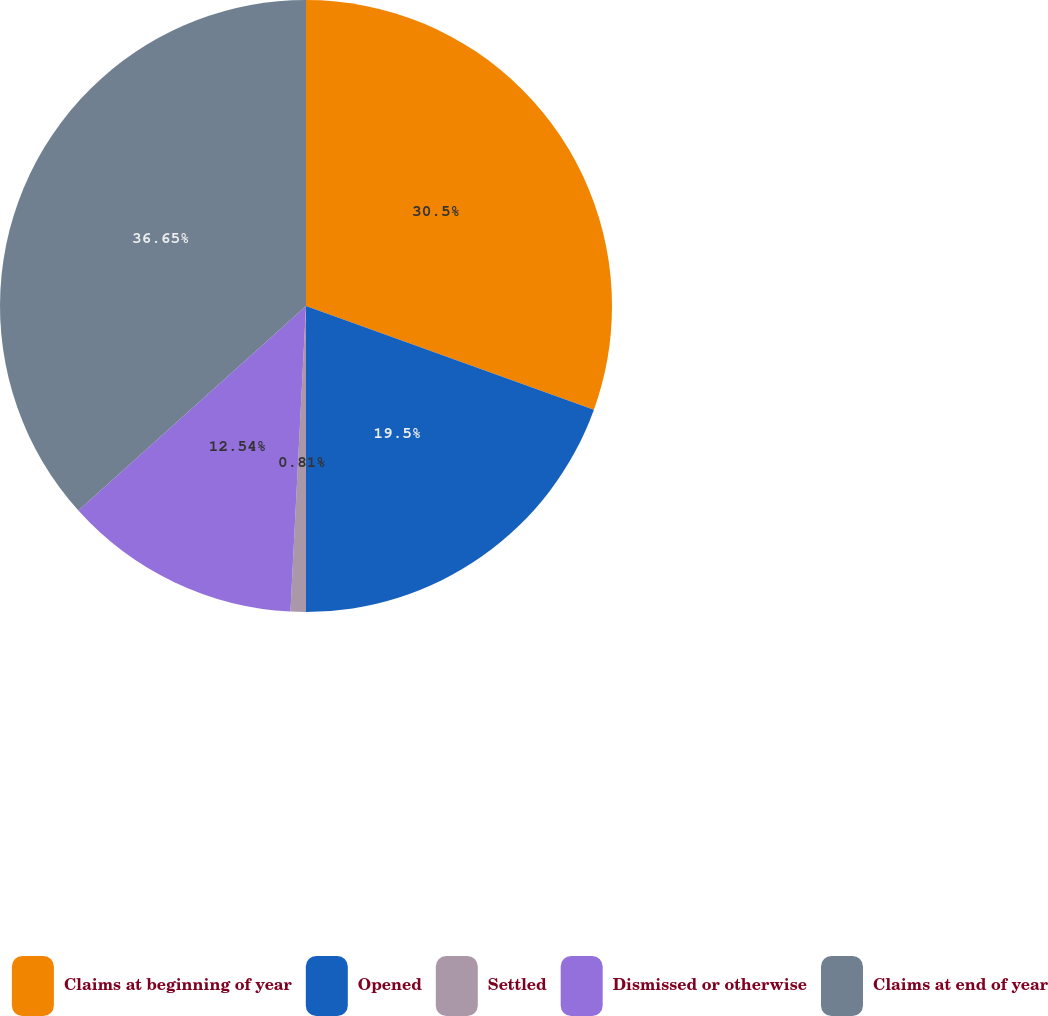<chart> <loc_0><loc_0><loc_500><loc_500><pie_chart><fcel>Claims at beginning of year<fcel>Opened<fcel>Settled<fcel>Dismissed or otherwise<fcel>Claims at end of year<nl><fcel>30.5%<fcel>19.5%<fcel>0.81%<fcel>12.54%<fcel>36.65%<nl></chart> 